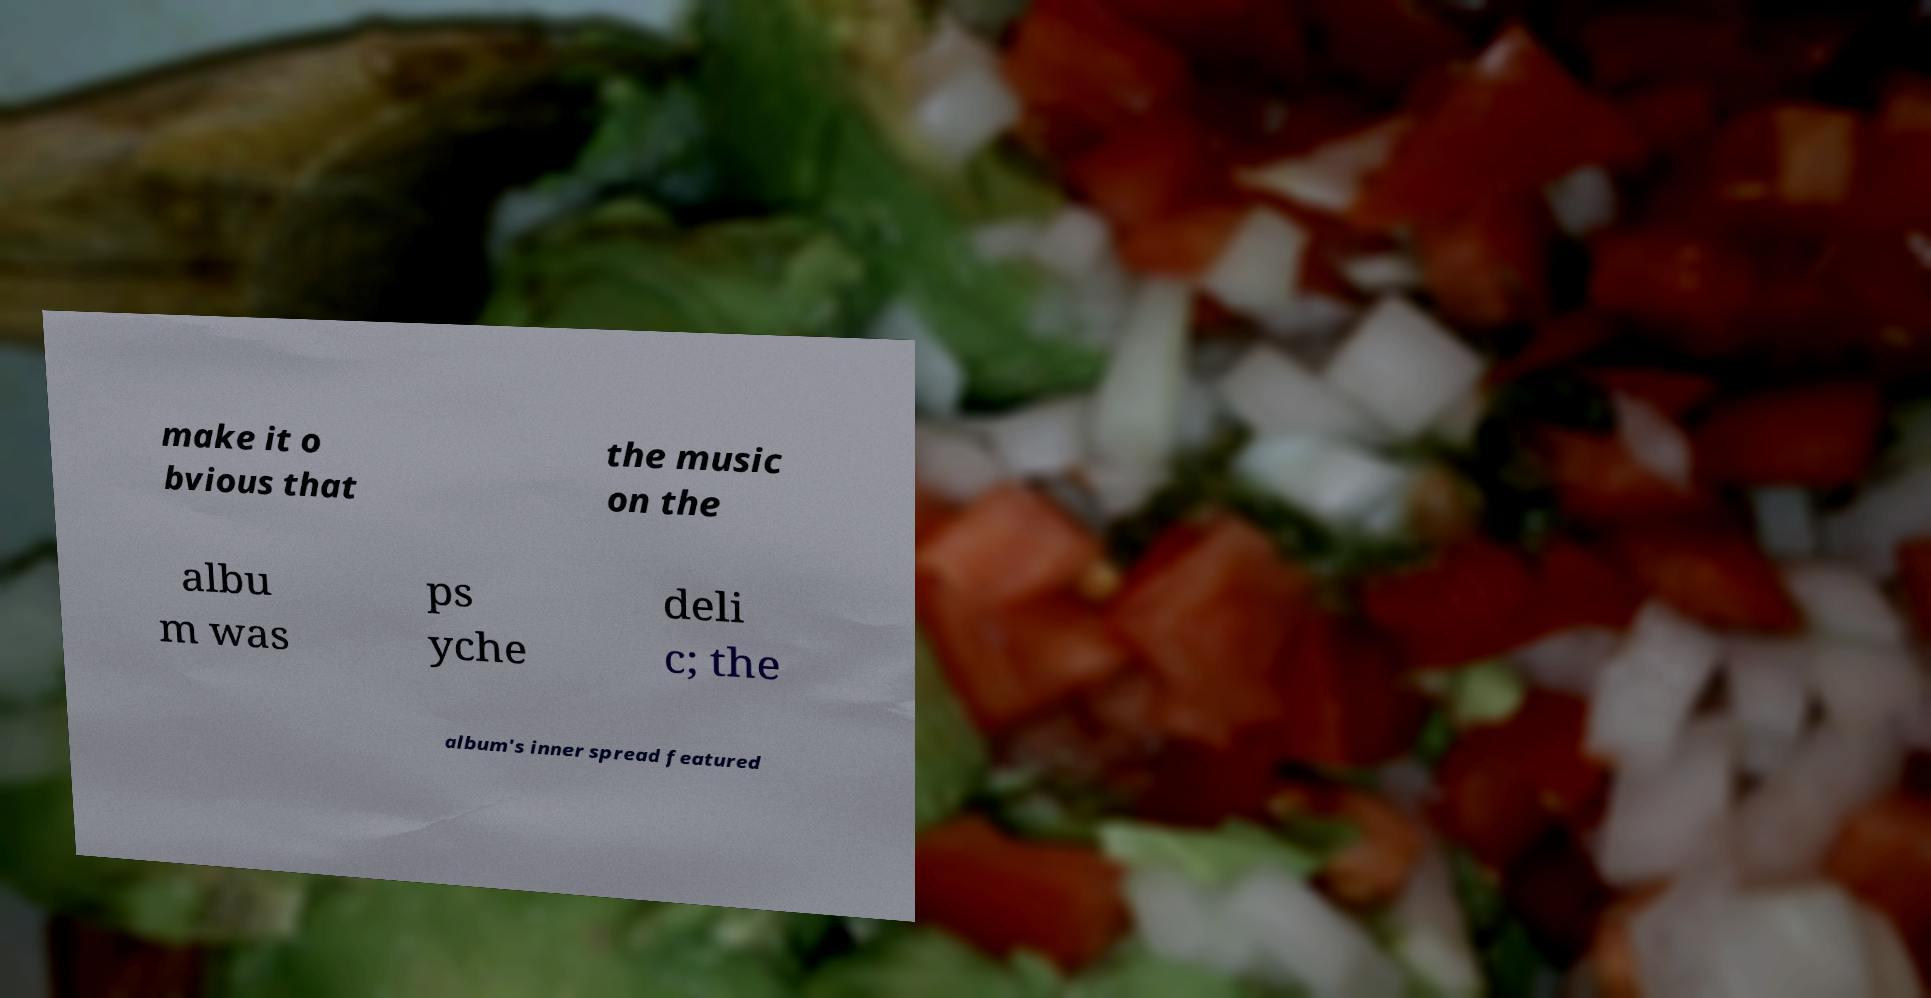What messages or text are displayed in this image? I need them in a readable, typed format. make it o bvious that the music on the albu m was ps yche deli c; the album's inner spread featured 